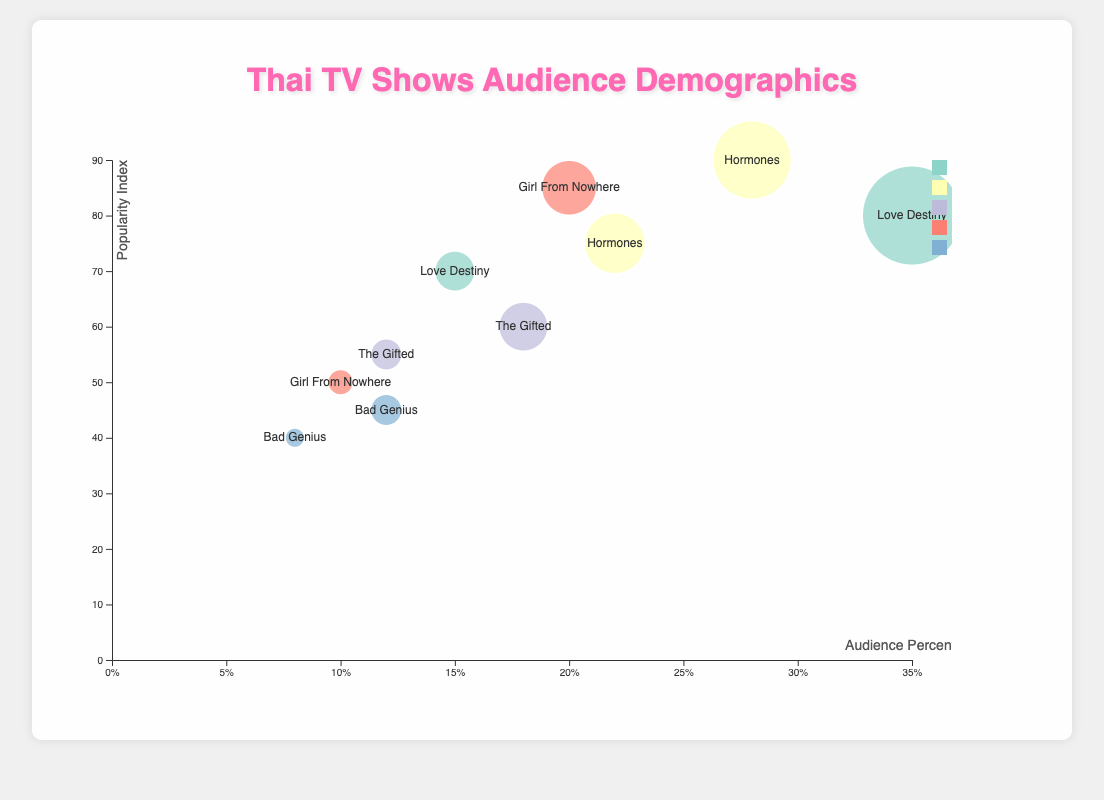How many shows have audience data for females in the age range 18-24? Look at the bubbles labeled by the show names and identify those where the gender is 'Female' and the age range is '18-24'.
Answer: One Which show has the highest percentage of male viewers aged 18-24? Check the data points with 'Male' gender and '18-24' age range, then compare their percentages.
Answer: Love Destiny Which show has the lowest popularity index? Examine the y-axis (Popularity Index) and identify the data point with the lowest value.
Answer: Bad Genius What is the difference in audience percentage between female and male viewers for "Hormones"? Find the percentages of female and male viewers for "Hormones" and calculate the difference: 28% - 22%.
Answer: 6% Compare the popularity index of "The Gifted" and "Girl From Nowhere" for female viewers. Which is higher? Identify the popularity index for female viewers in both shows and compare them: "The Gifted" is 60, "Girl From Nowhere" is 85.
Answer: Girl From Nowhere What is the sum of audience percentages for male viewers across all shows? Add up the percentages for male viewers across all shows: 15% + 22% + 12% + 10% + 8%.
Answer: 67% Which show has the largest bubble on the chart and what does it represent? The size of the bubbles represents the audience percentage, so the largest bubble corresponds to the greatest percentage. Identify the bubble and what it represents.
Answer: Love Destiny, Female, 18-24, 35% How many shows have a popularity index higher than 70? Count the bubbles with a y-value (Popularity Index) greater than 70.
Answer: Three Which age range has the highest average percentage of viewers across all shows? Calculate the average audience percentage for each age range and identify the highest one.
Answer: 18-24 Are there more male or female viewers overall in the 35-44 age range? Compare the percentages for male and female viewers in the 35-44 age range: Female 18%, Male 12%.
Answer: Female How does the popularity index for "Hormones" male viewers compare to that of "Love Destiny" male viewers? Compare the popularity indices of the two points: Hormones, Male, 75 and Love Destiny, Male, 70.
Answer: Hormones 